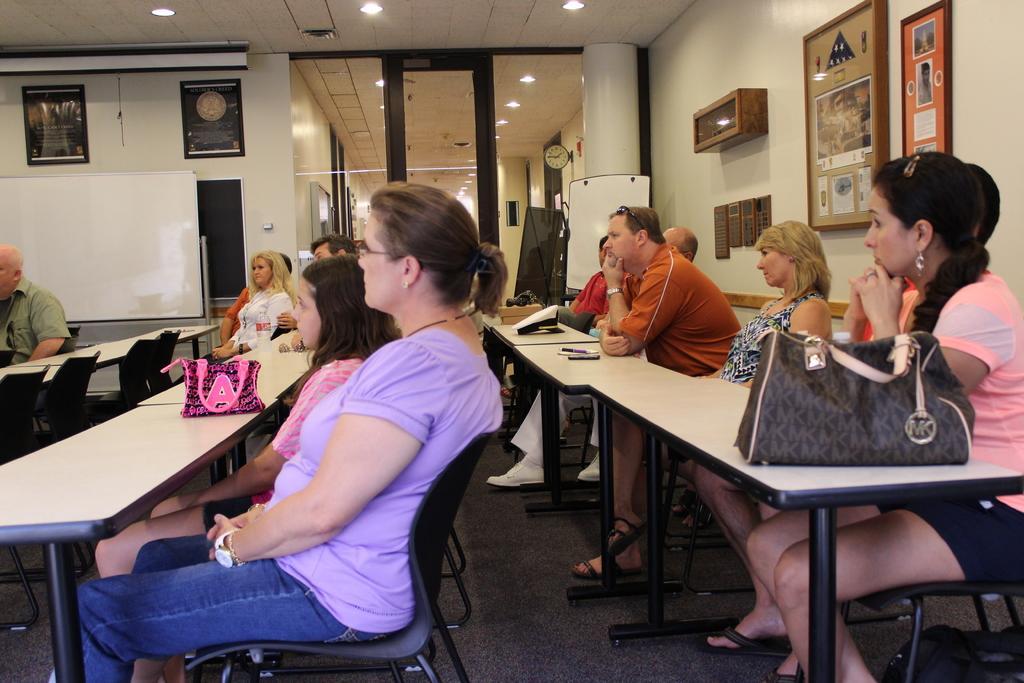How would you summarize this image in a sentence or two? We can see frames over a wall. This is ceiling and lights. This is adoor. we can see persons sitiing on chairs infront of a table and on the table we can see pen , mobile and handbags. This is a floor. 